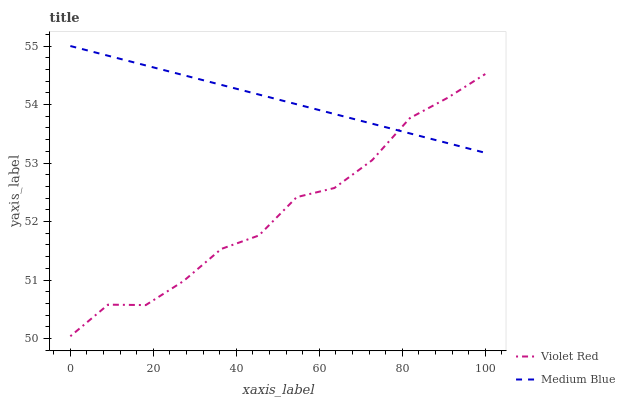Does Medium Blue have the minimum area under the curve?
Answer yes or no. No. Is Medium Blue the roughest?
Answer yes or no. No. Does Medium Blue have the lowest value?
Answer yes or no. No. 